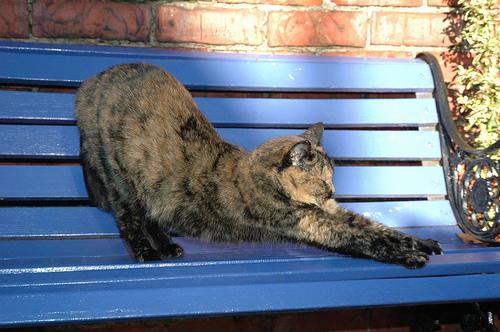What color is the bench?
Answer briefly. Blue. How many people are on the bench?
Short answer required. 0. What is the catch stretching on?
Give a very brief answer. Bench. 